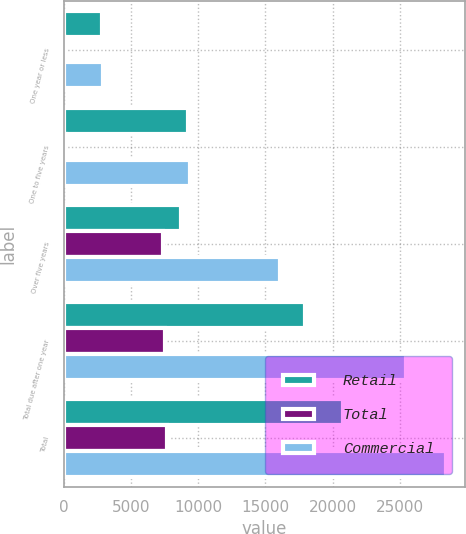<chart> <loc_0><loc_0><loc_500><loc_500><stacked_bar_chart><ecel><fcel>One year or less<fcel>One to five years<fcel>Over five years<fcel>Total due after one year<fcel>Total<nl><fcel>Retail<fcel>2820<fcel>9228.1<fcel>8702.7<fcel>17930.8<fcel>20750.8<nl><fcel>Total<fcel>89.7<fcel>197.2<fcel>7373.2<fcel>7570.4<fcel>7660.1<nl><fcel>Commercial<fcel>2909.7<fcel>9425.3<fcel>16075.9<fcel>25501.2<fcel>28410.9<nl></chart> 